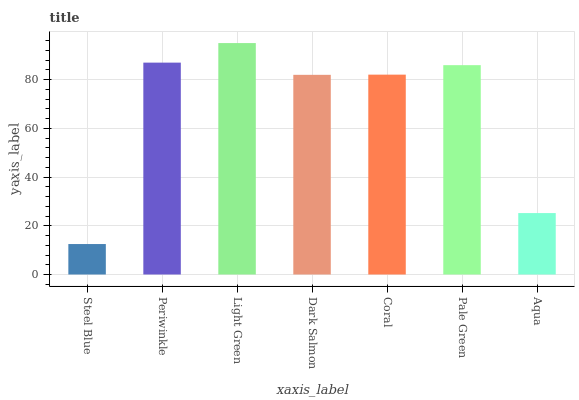Is Steel Blue the minimum?
Answer yes or no. Yes. Is Light Green the maximum?
Answer yes or no. Yes. Is Periwinkle the minimum?
Answer yes or no. No. Is Periwinkle the maximum?
Answer yes or no. No. Is Periwinkle greater than Steel Blue?
Answer yes or no. Yes. Is Steel Blue less than Periwinkle?
Answer yes or no. Yes. Is Steel Blue greater than Periwinkle?
Answer yes or no. No. Is Periwinkle less than Steel Blue?
Answer yes or no. No. Is Coral the high median?
Answer yes or no. Yes. Is Coral the low median?
Answer yes or no. Yes. Is Steel Blue the high median?
Answer yes or no. No. Is Steel Blue the low median?
Answer yes or no. No. 